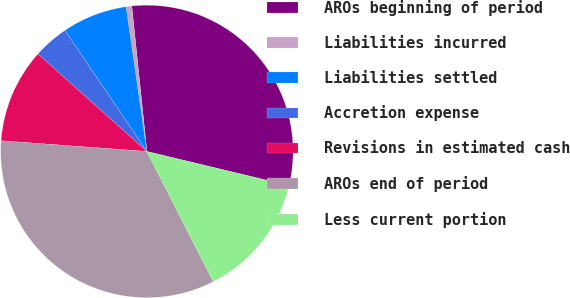<chart> <loc_0><loc_0><loc_500><loc_500><pie_chart><fcel>AROs beginning of period<fcel>Liabilities incurred<fcel>Liabilities settled<fcel>Accretion expense<fcel>Revisions in estimated cash<fcel>AROs end of period<fcel>Less current portion<nl><fcel>30.4%<fcel>0.63%<fcel>7.19%<fcel>3.91%<fcel>10.46%<fcel>33.68%<fcel>13.74%<nl></chart> 